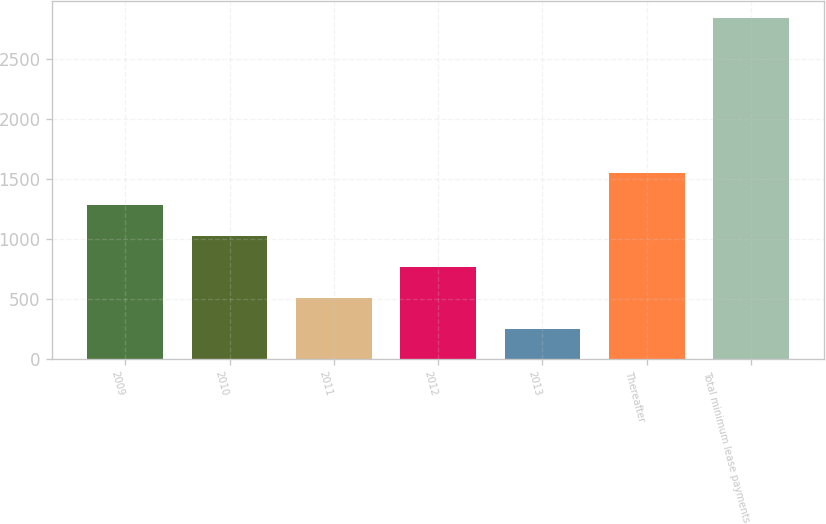Convert chart to OTSL. <chart><loc_0><loc_0><loc_500><loc_500><bar_chart><fcel>2009<fcel>2010<fcel>2011<fcel>2012<fcel>2013<fcel>Thereafter<fcel>Total minimum lease payments<nl><fcel>1285.4<fcel>1025.8<fcel>506.6<fcel>766.2<fcel>247<fcel>1545<fcel>2843<nl></chart> 